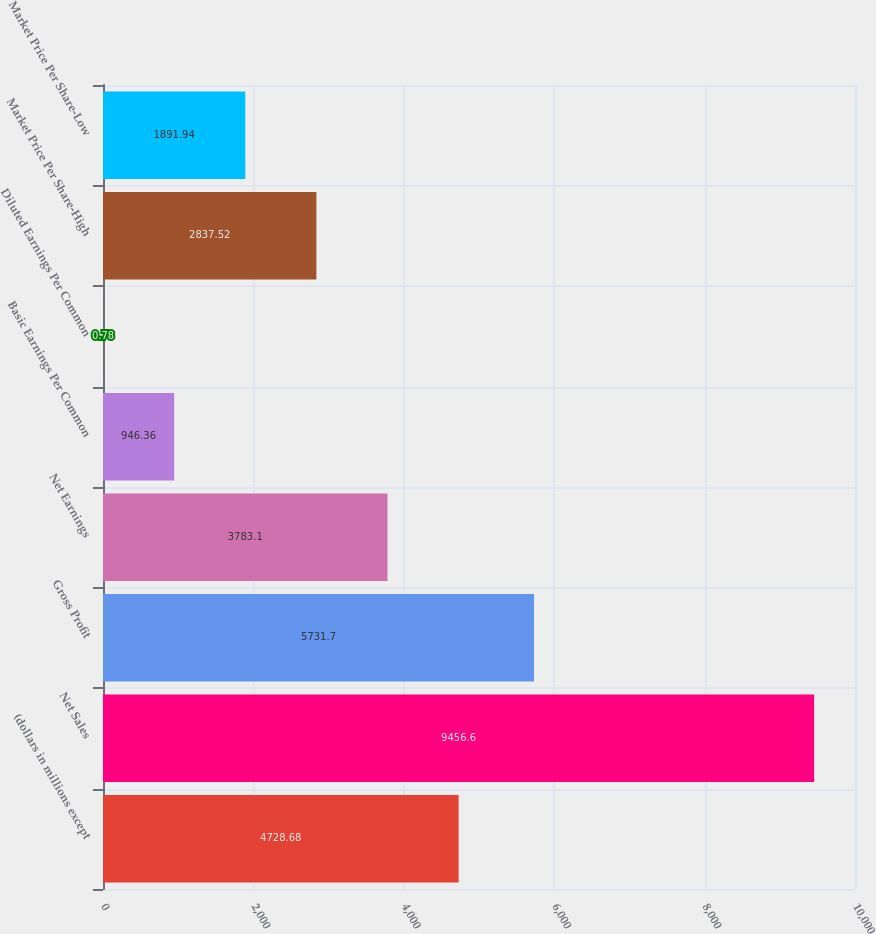<chart> <loc_0><loc_0><loc_500><loc_500><bar_chart><fcel>(dollars in millions except<fcel>Net Sales<fcel>Gross Profit<fcel>Net Earnings<fcel>Basic Earnings Per Common<fcel>Diluted Earnings Per Common<fcel>Market Price Per Share-High<fcel>Market Price Per Share-Low<nl><fcel>4728.68<fcel>9456.6<fcel>5731.7<fcel>3783.1<fcel>946.36<fcel>0.78<fcel>2837.52<fcel>1891.94<nl></chart> 